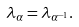<formula> <loc_0><loc_0><loc_500><loc_500>\lambda _ { \alpha } = \lambda _ { \alpha ^ { - 1 } } .</formula> 